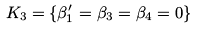Convert formula to latex. <formula><loc_0><loc_0><loc_500><loc_500>K _ { 3 } = \{ \beta ^ { \prime } _ { 1 } = \beta _ { 3 } = \beta _ { 4 } = 0 \}</formula> 